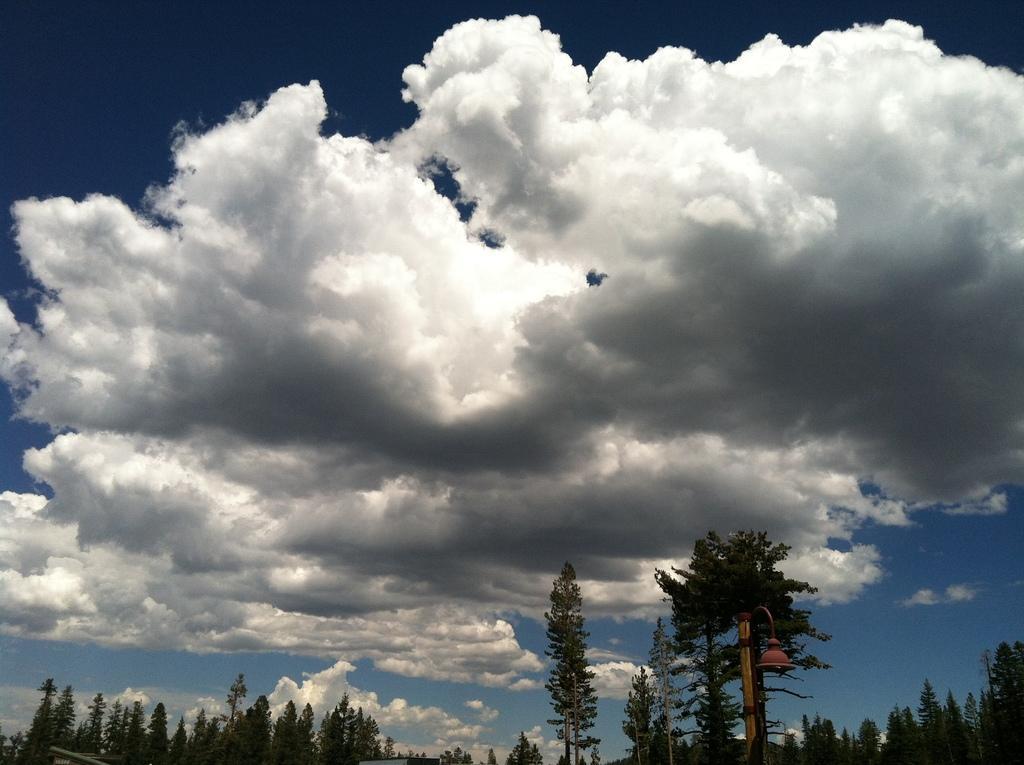How would you summarize this image in a sentence or two? In this picture I can see trees and a blue cloudy Sky. 